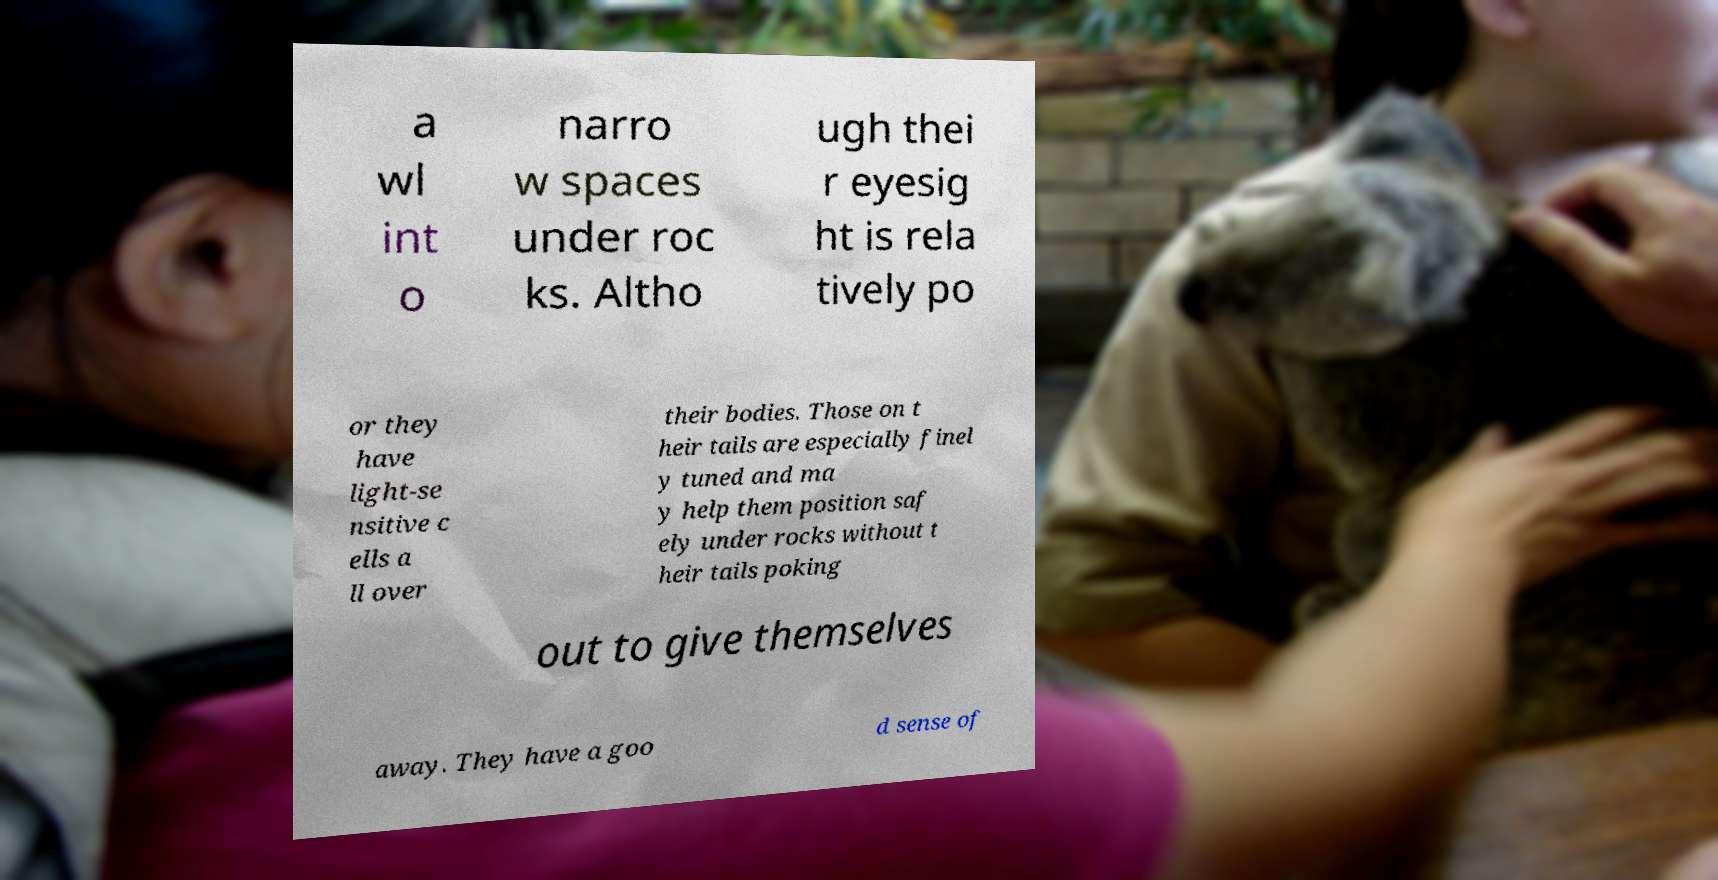Can you read and provide the text displayed in the image?This photo seems to have some interesting text. Can you extract and type it out for me? a wl int o narro w spaces under roc ks. Altho ugh thei r eyesig ht is rela tively po or they have light-se nsitive c ells a ll over their bodies. Those on t heir tails are especially finel y tuned and ma y help them position saf ely under rocks without t heir tails poking out to give themselves away. They have a goo d sense of 